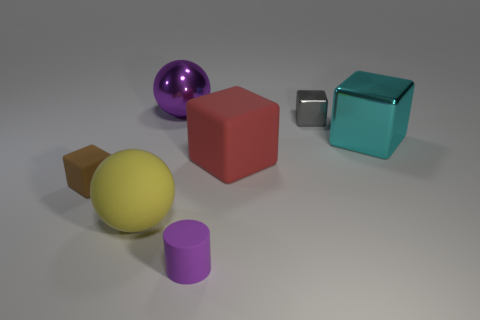Subtract all large cyan cubes. How many cubes are left? 3 Add 1 large metallic balls. How many objects exist? 8 Subtract all brown blocks. How many blocks are left? 3 Subtract 4 cubes. How many cubes are left? 0 Add 4 big matte things. How many big matte things are left? 6 Add 3 large objects. How many large objects exist? 7 Subtract 0 brown cylinders. How many objects are left? 7 Subtract all blocks. How many objects are left? 3 Subtract all yellow blocks. Subtract all purple cylinders. How many blocks are left? 4 Subtract all yellow cubes. How many yellow balls are left? 1 